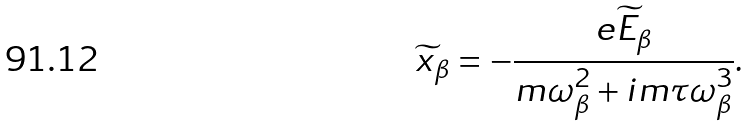<formula> <loc_0><loc_0><loc_500><loc_500>\widetilde { x } _ { \beta } = - \frac { e \widetilde { E } _ { \beta } } { m \omega _ { \beta } ^ { 2 } + i m \tau \omega _ { \beta } ^ { 3 } } .</formula> 